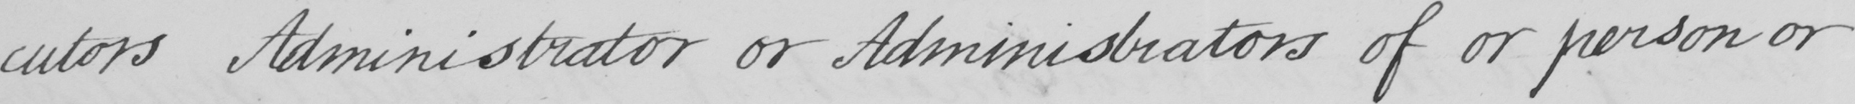Please transcribe the handwritten text in this image. -cutors Administrator or Administrators of or person or 